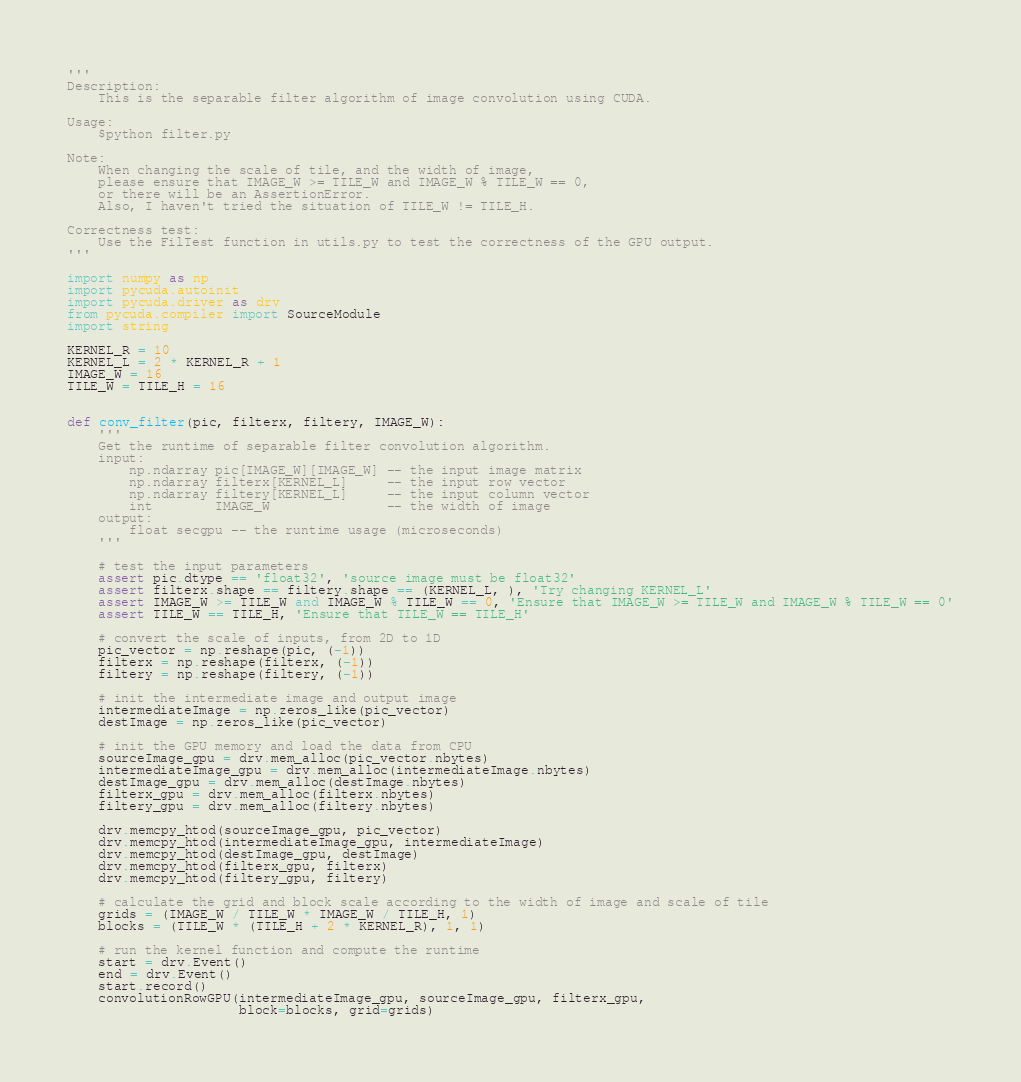<code> <loc_0><loc_0><loc_500><loc_500><_Python_>'''
Description:
    This is the separable filter algorithm of image convolution using CUDA.

Usage:
    $python filter.py

Note:
    When changing the scale of tile, and the width of image,
    please ensure that IMAGE_W >= TILE_W and IMAGE_W % TILE_W == 0,
    or there will be an AssertionError.
    Also, I haven't tried the situation of TILE_W != TILE_H.

Correctness test:
    Use the FilTest function in utils.py to test the correctness of the GPU output.
'''

import numpy as np
import pycuda.autoinit
import pycuda.driver as drv
from pycuda.compiler import SourceModule
import string

KERNEL_R = 10
KERNEL_L = 2 * KERNEL_R + 1
IMAGE_W = 16
TILE_W = TILE_H = 16


def conv_filter(pic, filterx, filtery, IMAGE_W):
    '''
    Get the runtime of separable filter convolution algorithm.
    input:
        np.ndarray pic[IMAGE_W][IMAGE_W] -- the input image matrix
        np.ndarray filterx[KERNEL_L]     -- the input row vector
        np.ndarray filtery[KERNEL_L]     -- the input column vector
        int        IMAGE_W               -- the width of image
    output:
        float secgpu -- the runtime usage (microseconds) 
    '''

    # test the input parameters
    assert pic.dtype == 'float32', 'source image must be float32'
    assert filterx.shape == filtery.shape == (KERNEL_L, ), 'Try changing KERNEL_L'
    assert IMAGE_W >= TILE_W and IMAGE_W % TILE_W == 0, 'Ensure that IMAGE_W >= TILE_W and IMAGE_W % TILE_W == 0'
    assert TILE_W == TILE_H, 'Ensure that TILE_W == TILE_H'

    # convert the scale of inputs, from 2D to 1D
    pic_vector = np.reshape(pic, (-1))
    filterx = np.reshape(filterx, (-1))
    filtery = np.reshape(filtery, (-1))

    # init the intermediate image and output image
    intermediateImage = np.zeros_like(pic_vector)
    destImage = np.zeros_like(pic_vector)

    # init the GPU memory and load the data from CPU
    sourceImage_gpu = drv.mem_alloc(pic_vector.nbytes)
    intermediateImage_gpu = drv.mem_alloc(intermediateImage.nbytes)
    destImage_gpu = drv.mem_alloc(destImage.nbytes)
    filterx_gpu = drv.mem_alloc(filterx.nbytes)
    filtery_gpu = drv.mem_alloc(filtery.nbytes)

    drv.memcpy_htod(sourceImage_gpu, pic_vector)
    drv.memcpy_htod(intermediateImage_gpu, intermediateImage)
    drv.memcpy_htod(destImage_gpu, destImage)
    drv.memcpy_htod(filterx_gpu, filterx)
    drv.memcpy_htod(filtery_gpu, filtery)

    # calculate the grid and block scale according to the width of image and scale of tile
    grids = (IMAGE_W / TILE_W * IMAGE_W / TILE_H, 1)
    blocks = (TILE_W * (TILE_H + 2 * KERNEL_R), 1, 1)

    # run the kernel function and compute the runtime
    start = drv.Event()
    end = drv.Event()
    start.record()
    convolutionRowGPU(intermediateImage_gpu, sourceImage_gpu, filterx_gpu,
                      block=blocks, grid=grids)</code> 